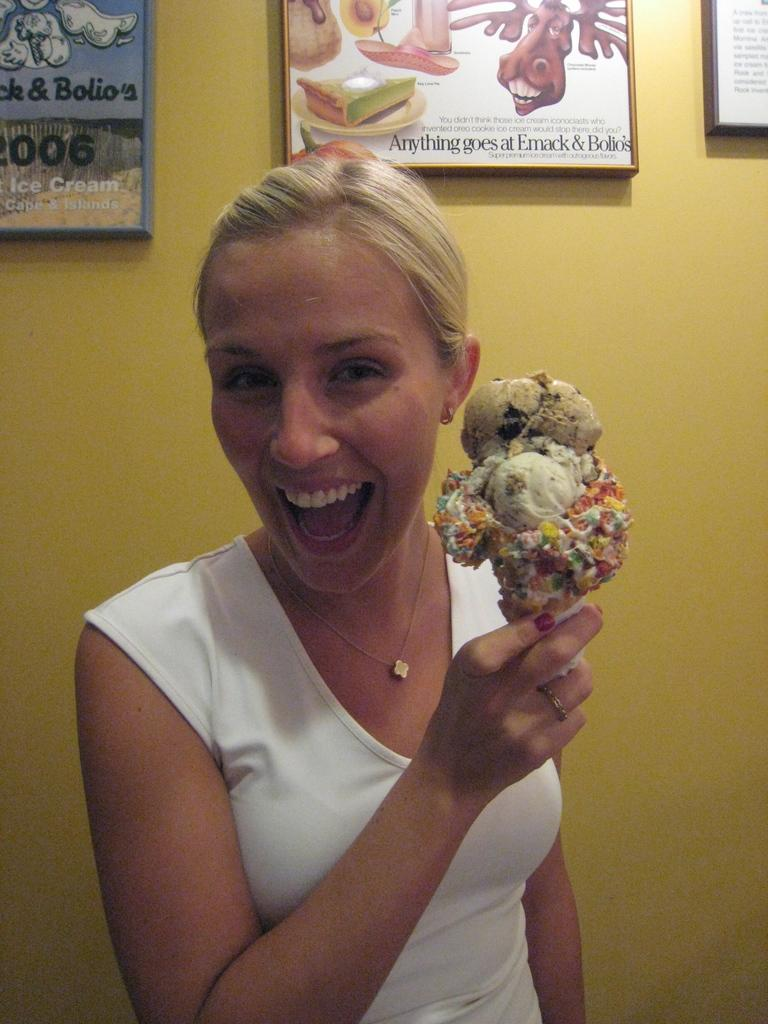Who is the main subject in the image? There is a woman in the image. What is the woman wearing? The woman is wearing a white top. What is the woman holding in the image? The woman is holding an ice-cream. What can be seen in the background of the image? There is a wall with frames in the background of the image. What type of goose is sitting on the ice-cream in the image? There is no goose present in the image; the woman is holding an ice-cream. What flavor of cracker is the woman eating in the image? There is no cracker present in the image; the woman is holding an ice-cream. 